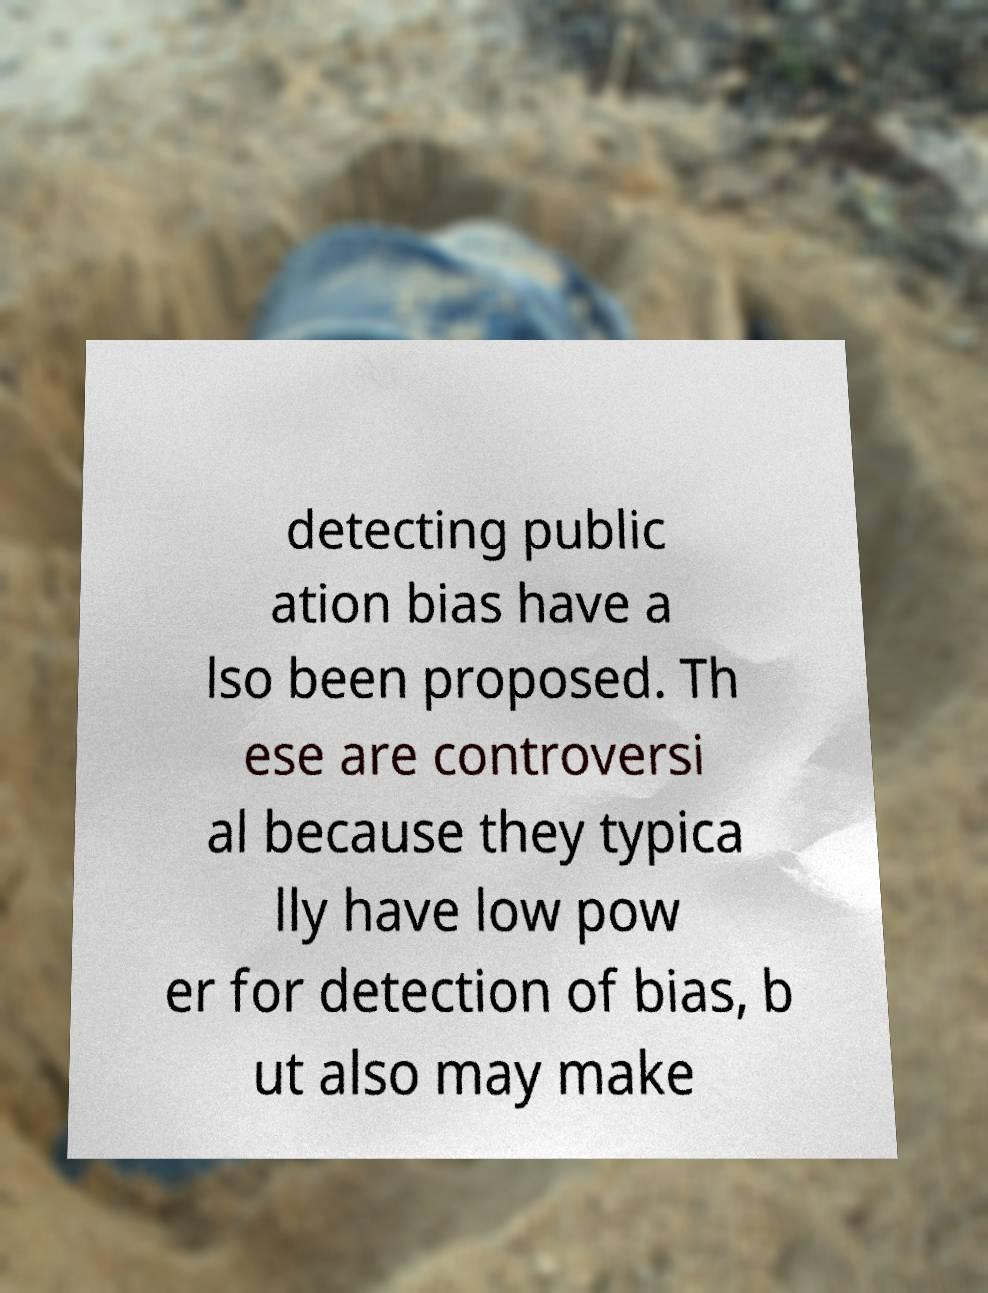Please read and relay the text visible in this image. What does it say? detecting public ation bias have a lso been proposed. Th ese are controversi al because they typica lly have low pow er for detection of bias, b ut also may make 